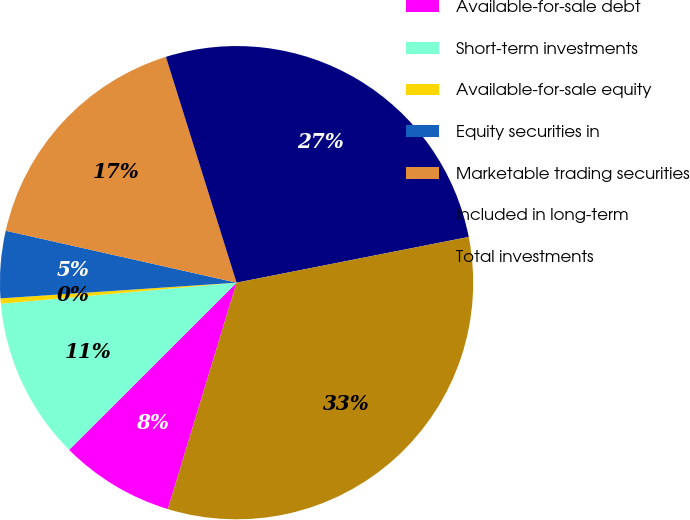Convert chart to OTSL. <chart><loc_0><loc_0><loc_500><loc_500><pie_chart><fcel>Available-for-sale debt<fcel>Short-term investments<fcel>Available-for-sale equity<fcel>Equity securities in<fcel>Marketable trading securities<fcel>Included in long-term<fcel>Total investments<nl><fcel>7.82%<fcel>11.07%<fcel>0.36%<fcel>4.58%<fcel>16.65%<fcel>26.73%<fcel>32.79%<nl></chart> 